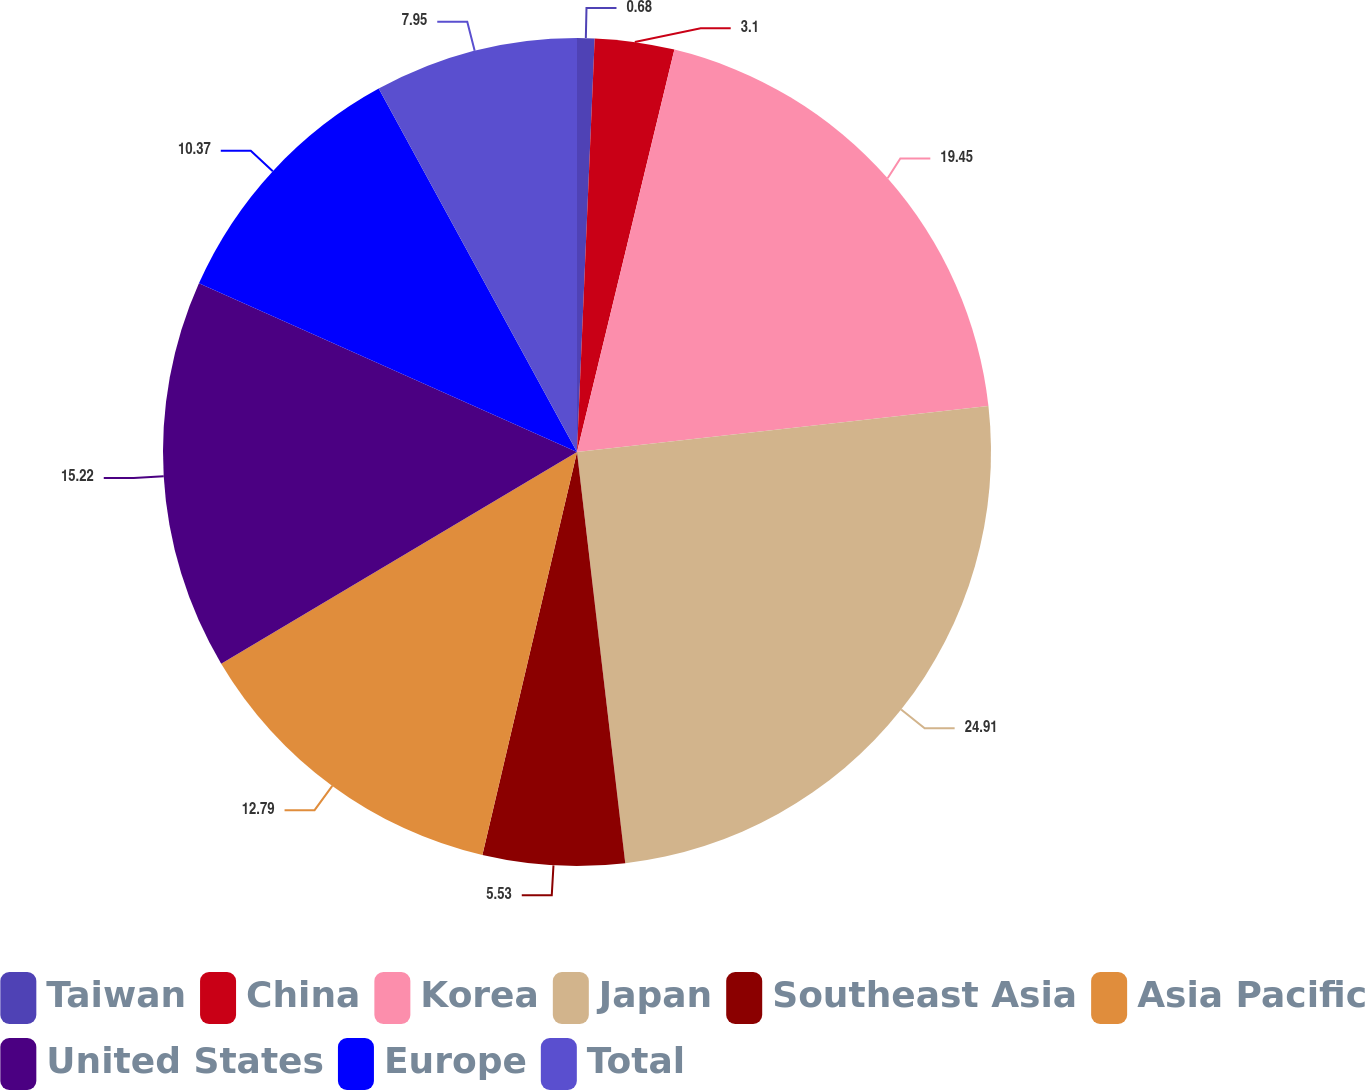Convert chart to OTSL. <chart><loc_0><loc_0><loc_500><loc_500><pie_chart><fcel>Taiwan<fcel>China<fcel>Korea<fcel>Japan<fcel>Southeast Asia<fcel>Asia Pacific<fcel>United States<fcel>Europe<fcel>Total<nl><fcel>0.68%<fcel>3.1%<fcel>19.45%<fcel>24.91%<fcel>5.53%<fcel>12.79%<fcel>15.22%<fcel>10.37%<fcel>7.95%<nl></chart> 